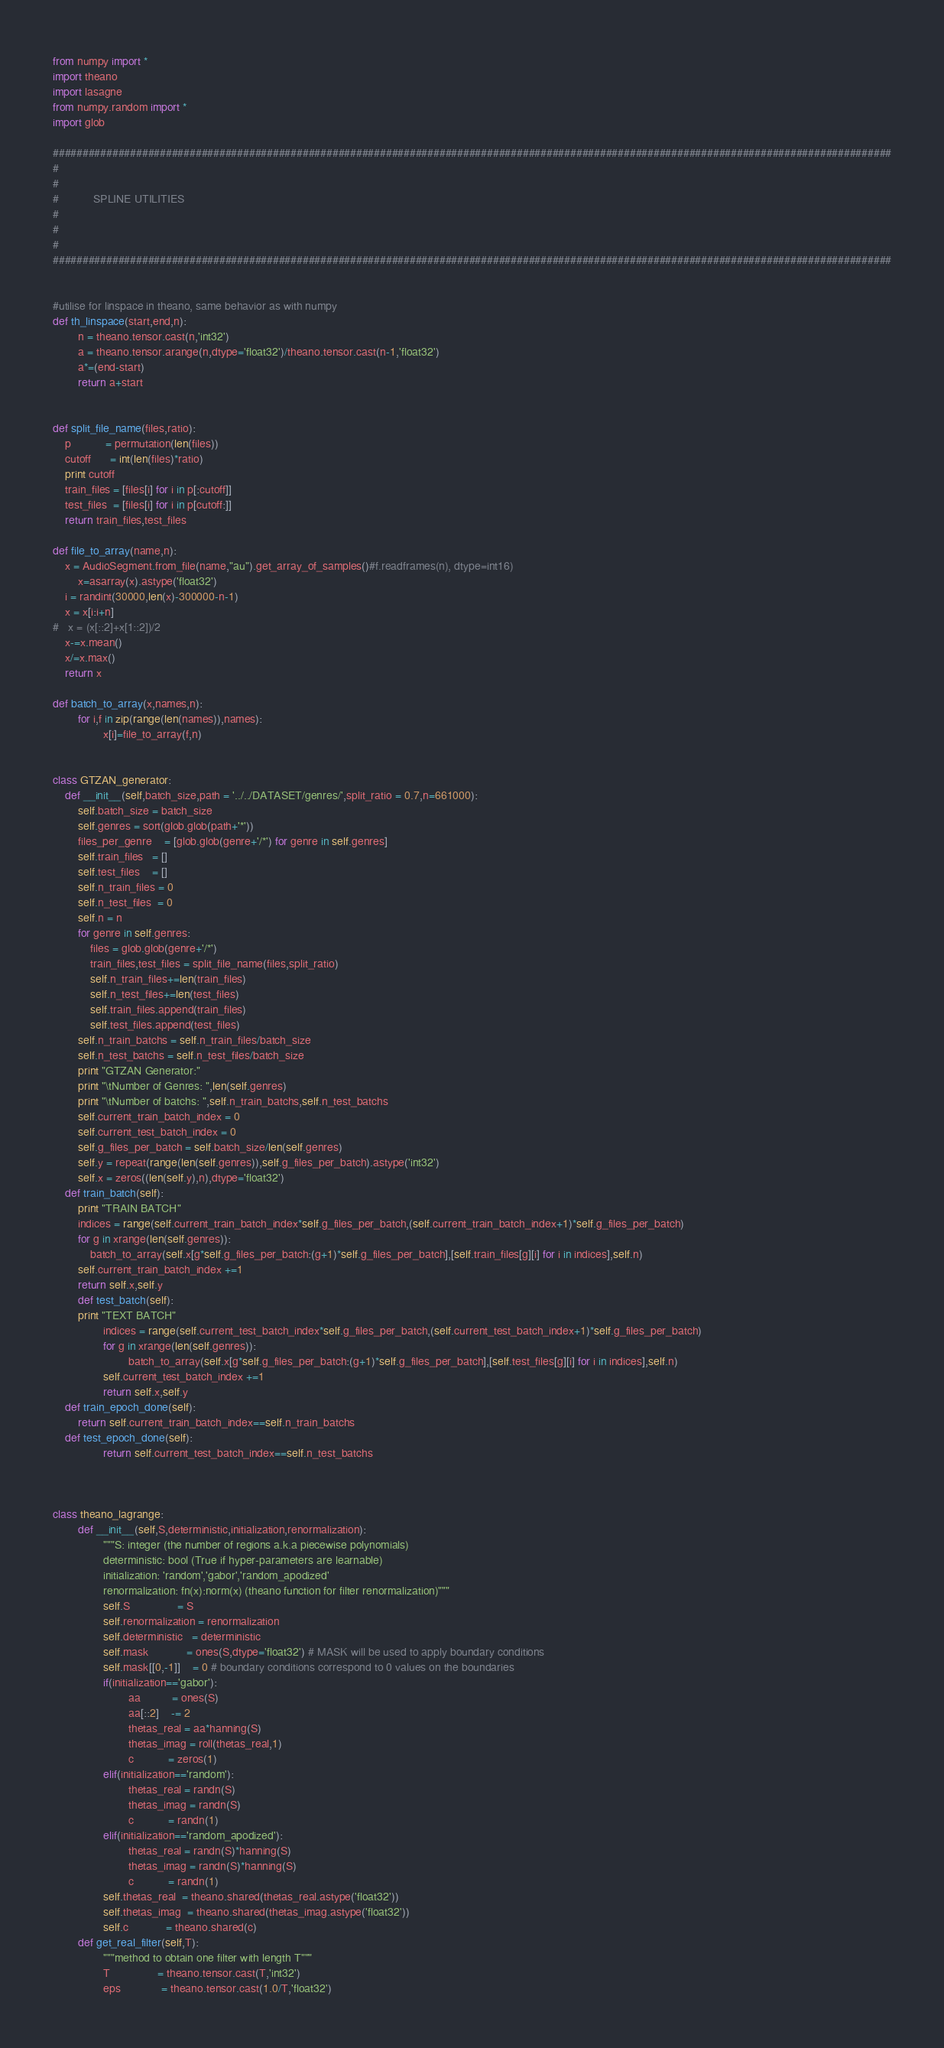<code> <loc_0><loc_0><loc_500><loc_500><_Python_>from numpy import *
import theano
import lasagne
from numpy.random import *
import glob

#############################################################################################################################################
#
#
#			SPLINE UTILITIES
#
#
#
#############################################################################################################################################


#utilise for linspace in theano, same behavior as with numpy
def th_linspace(start,end,n):
        n = theano.tensor.cast(n,'int32')
        a = theano.tensor.arange(n,dtype='float32')/theano.tensor.cast(n-1,'float32')
        a*=(end-start)
        return a+start


def split_file_name(files,ratio):
	p           = permutation(len(files))
	cutoff      = int(len(files)*ratio)
	print cutoff
	train_files = [files[i] for i in p[:cutoff]]
	test_files  = [files[i] for i in p[cutoff:]]
	return train_files,test_files

def file_to_array(name,n):
	x = AudioSegment.from_file(name,"au").get_array_of_samples()#f.readframes(n), dtype=int16)
        x=asarray(x).astype('float32')
	i = randint(30000,len(x)-300000-n-1)
	x = x[i:i+n]
#	x = (x[::2]+x[1::2])/2
	x-=x.mean()
	x/=x.max()
	return x

def batch_to_array(x,names,n):
        for i,f in zip(range(len(names)),names):
                x[i]=file_to_array(f,n)


class GTZAN_generator:
	def __init__(self,batch_size,path = '../../DATASET/genres/',split_ratio = 0.7,n=661000):
		self.batch_size = batch_size 
		self.genres = sort(glob.glob(path+'*'))
		files_per_genre    = [glob.glob(genre+'/*') for genre in self.genres]
		self.train_files   = []
		self.test_files    = []
		self.n_train_files = 0
		self.n_test_files  = 0
		self.n = n
		for genre in self.genres:
			files = glob.glob(genre+'/*')
			train_files,test_files = split_file_name(files,split_ratio)
			self.n_train_files+=len(train_files)
			self.n_test_files+=len(test_files)
			self.train_files.append(train_files)
			self.test_files.append(test_files)
		self.n_train_batchs = self.n_train_files/batch_size
		self.n_test_batchs = self.n_test_files/batch_size
		print "GTZAN Generator:"
		print "\tNumber of Genres: ",len(self.genres)
		print "\tNumber of batchs: ",self.n_train_batchs,self.n_test_batchs
		self.current_train_batch_index = 0
		self.current_test_batch_index = 0
		self.g_files_per_batch = self.batch_size/len(self.genres)
		self.y = repeat(range(len(self.genres)),self.g_files_per_batch).astype('int32')
		self.x = zeros((len(self.y),n),dtype='float32')
	def train_batch(self):
		print "TRAIN BATCH"
		indices = range(self.current_train_batch_index*self.g_files_per_batch,(self.current_train_batch_index+1)*self.g_files_per_batch)
		for g in xrange(len(self.genres)):
			batch_to_array(self.x[g*self.g_files_per_batch:(g+1)*self.g_files_per_batch],[self.train_files[g][i] for i in indices],self.n)
		self.current_train_batch_index +=1
		return self.x,self.y
        def test_batch(self):
		print "TEXT BATCH"
                indices = range(self.current_test_batch_index*self.g_files_per_batch,(self.current_test_batch_index+1)*self.g_files_per_batch)
                for g in xrange(len(self.genres)):
                        batch_to_array(self.x[g*self.g_files_per_batch:(g+1)*self.g_files_per_batch],[self.test_files[g][i] for i in indices],self.n)
                self.current_test_batch_index +=1
                return self.x,self.y
	def train_epoch_done(self):
		return self.current_train_batch_index==self.n_train_batchs
	def test_epoch_done(self):
                return self.current_test_batch_index==self.n_test_batchs



class theano_lagrange:
        def __init__(self,S,deterministic,initialization,renormalization):
                """S: integer (the number of regions a.k.a piecewise polynomials)
                deterministic: bool (True if hyper-parameters are learnable)
                initialization: 'random','gabor','random_apodized' 
                renormalization: fn(x):norm(x) (theano function for filter renormalization)"""
                self.S               = S
                self.renormalization = renormalization
                self.deterministic   = deterministic
                self.mask            = ones(S,dtype='float32') # MASK will be used to apply boundary conditions
                self.mask[[0,-1]]    = 0 # boundary conditions correspond to 0 values on the boundaries
                if(initialization=='gabor'):
                        aa          = ones(S) 
                        aa[::2]    -= 2
                        thetas_real = aa*hanning(S)
                        thetas_imag = roll(thetas_real,1)
                        c           = zeros(1)
                elif(initialization=='random'):
                        thetas_real = randn(S)
                        thetas_imag = randn(S)
                        c           = randn(1)
                elif(initialization=='random_apodized'):
                        thetas_real = randn(S)*hanning(S)
                        thetas_imag = randn(S)*hanning(S)
                        c           = randn(1)
                self.thetas_real  = theano.shared(thetas_real.astype('float32'))
                self.thetas_imag  = theano.shared(thetas_imag.astype('float32'))
                self.c            = theano.shared(c)
        def get_real_filter(self,T):
                """method to obtain one filter with length T"""
                T               = theano.tensor.cast(T,'int32')
                eps             = theano.tensor.cast(1.0/T,'float32')</code> 